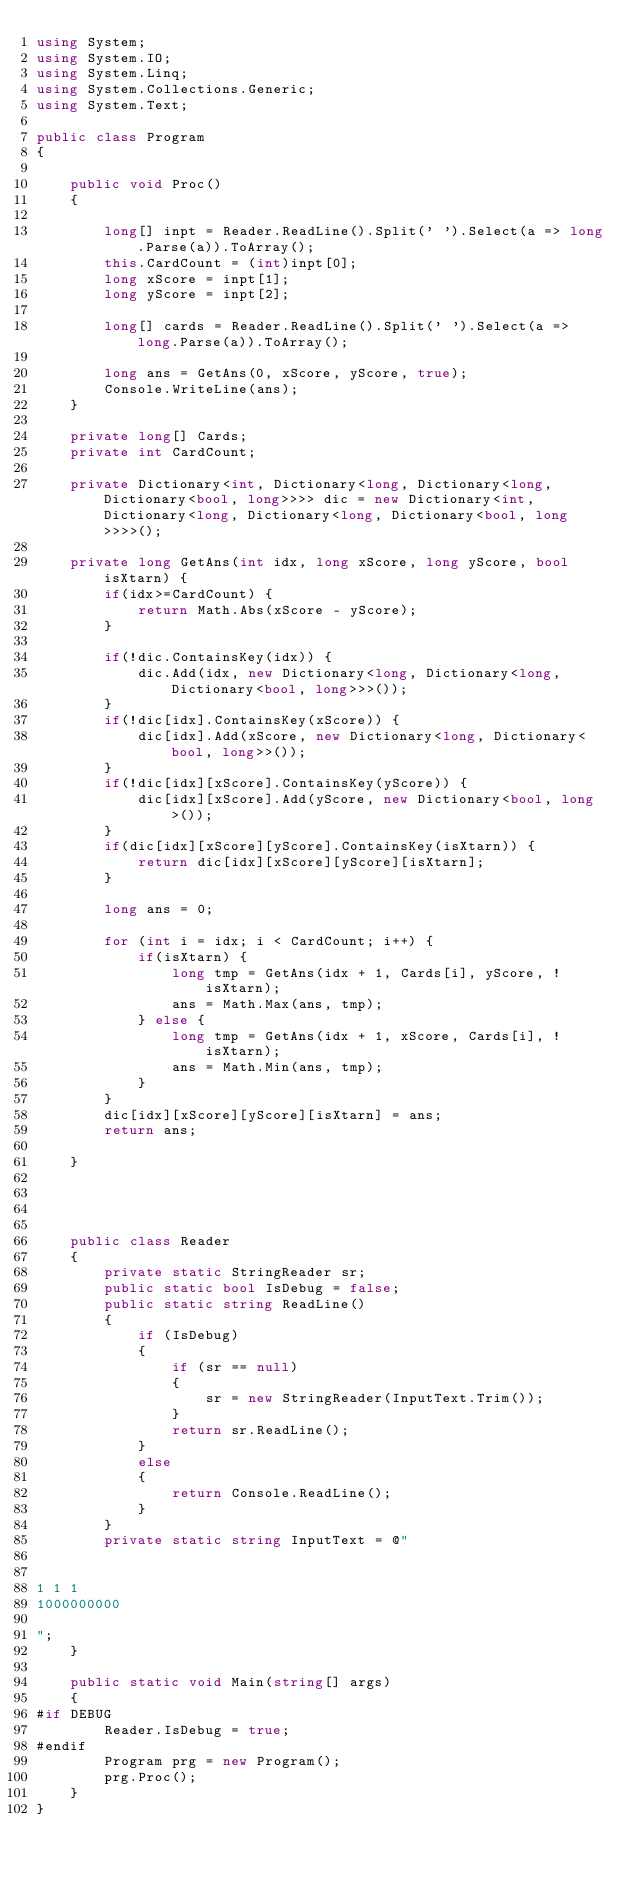<code> <loc_0><loc_0><loc_500><loc_500><_C#_>using System;
using System.IO;
using System.Linq;
using System.Collections.Generic;
using System.Text;

public class Program
{

    public void Proc()
    {

        long[] inpt = Reader.ReadLine().Split(' ').Select(a => long.Parse(a)).ToArray();
        this.CardCount = (int)inpt[0];
        long xScore = inpt[1];
        long yScore = inpt[2];

        long[] cards = Reader.ReadLine().Split(' ').Select(a => long.Parse(a)).ToArray();

        long ans = GetAns(0, xScore, yScore, true);
        Console.WriteLine(ans);
    }

    private long[] Cards;
    private int CardCount;

    private Dictionary<int, Dictionary<long, Dictionary<long, Dictionary<bool, long>>>> dic = new Dictionary<int, Dictionary<long, Dictionary<long, Dictionary<bool, long>>>>();

    private long GetAns(int idx, long xScore, long yScore, bool isXtarn) {
        if(idx>=CardCount) {
            return Math.Abs(xScore - yScore);
        }

        if(!dic.ContainsKey(idx)) {
            dic.Add(idx, new Dictionary<long, Dictionary<long, Dictionary<bool, long>>>());
        }
        if(!dic[idx].ContainsKey(xScore)) {
            dic[idx].Add(xScore, new Dictionary<long, Dictionary<bool, long>>());
        }
        if(!dic[idx][xScore].ContainsKey(yScore)) {
            dic[idx][xScore].Add(yScore, new Dictionary<bool, long>());
        }
        if(dic[idx][xScore][yScore].ContainsKey(isXtarn)) {
            return dic[idx][xScore][yScore][isXtarn];
        }

        long ans = 0;

        for (int i = idx; i < CardCount; i++) {
            if(isXtarn) {
                long tmp = GetAns(idx + 1, Cards[i], yScore, !isXtarn);
                ans = Math.Max(ans, tmp);
            } else {
                long tmp = GetAns(idx + 1, xScore, Cards[i], !isXtarn);
                ans = Math.Min(ans, tmp);
            }
        }
        dic[idx][xScore][yScore][isXtarn] = ans;
        return ans;

    }




    public class Reader
    {
        private static StringReader sr;
        public static bool IsDebug = false;
        public static string ReadLine()
        {
            if (IsDebug)
            {
                if (sr == null)
                {
                    sr = new StringReader(InputText.Trim());
                }
                return sr.ReadLine();
            }
            else
            {
                return Console.ReadLine();
            }
        }
        private static string InputText = @"


1 1 1
1000000000

";
    }

    public static void Main(string[] args)
    {
#if DEBUG
        Reader.IsDebug = true;
#endif
        Program prg = new Program();
        prg.Proc();
    }
}
</code> 